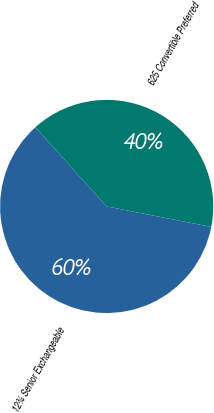Convert chart to OTSL. <chart><loc_0><loc_0><loc_500><loc_500><pie_chart><fcel>12¾ Senior Exchangeable<fcel>625 Convertible Preferred<nl><fcel>60.25%<fcel>39.75%<nl></chart> 